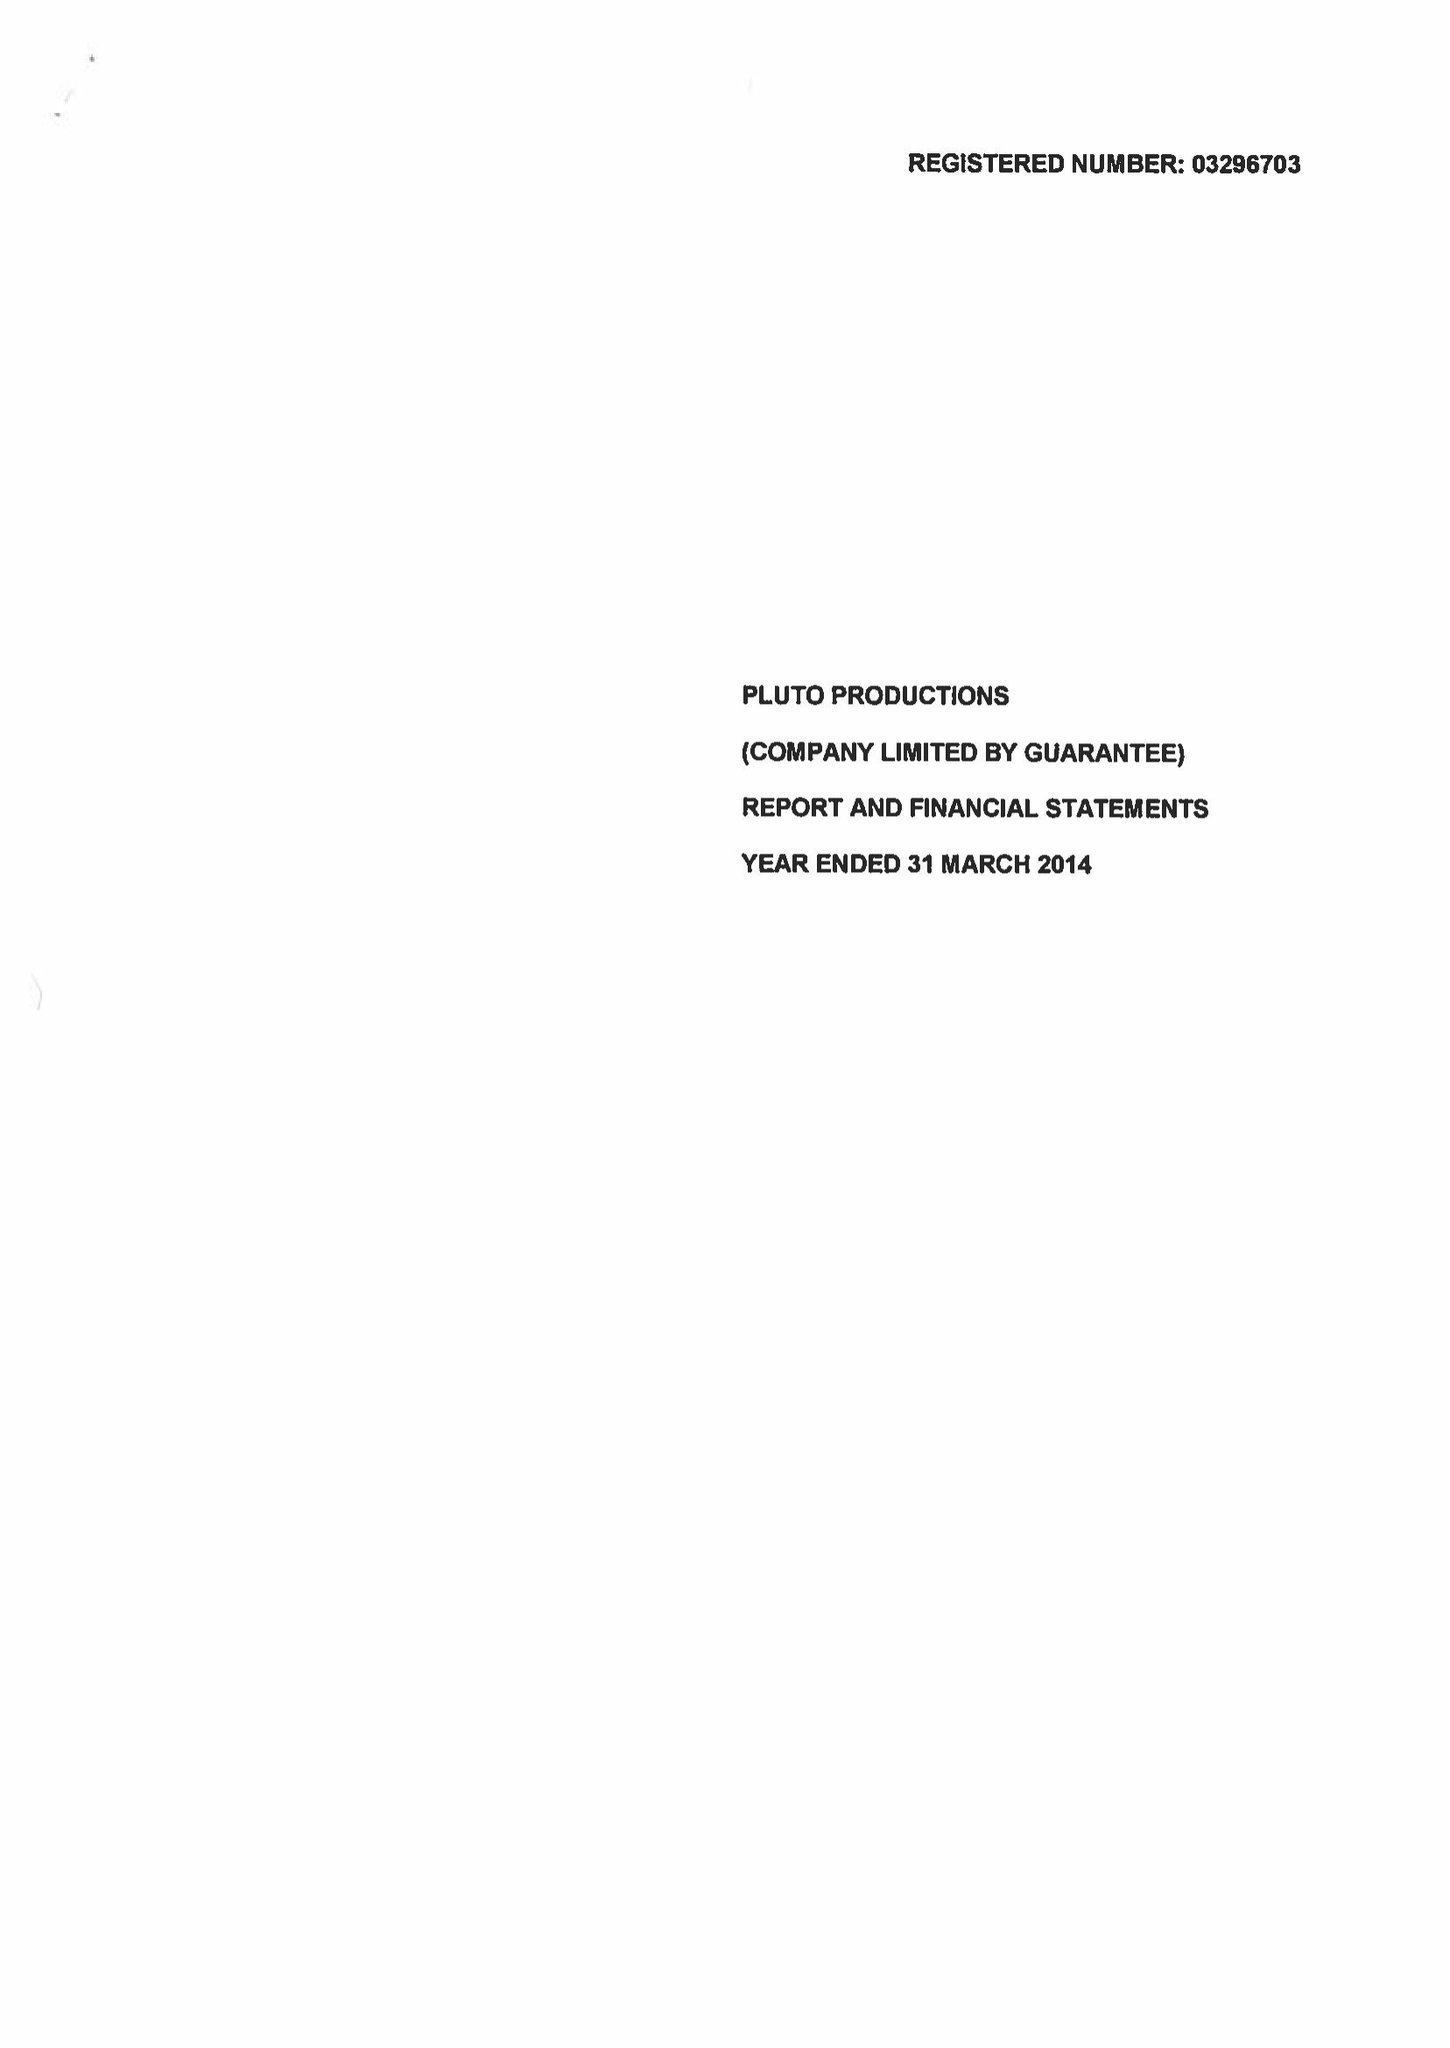What is the value for the income_annually_in_british_pounds?
Answer the question using a single word or phrase. 69544.00 